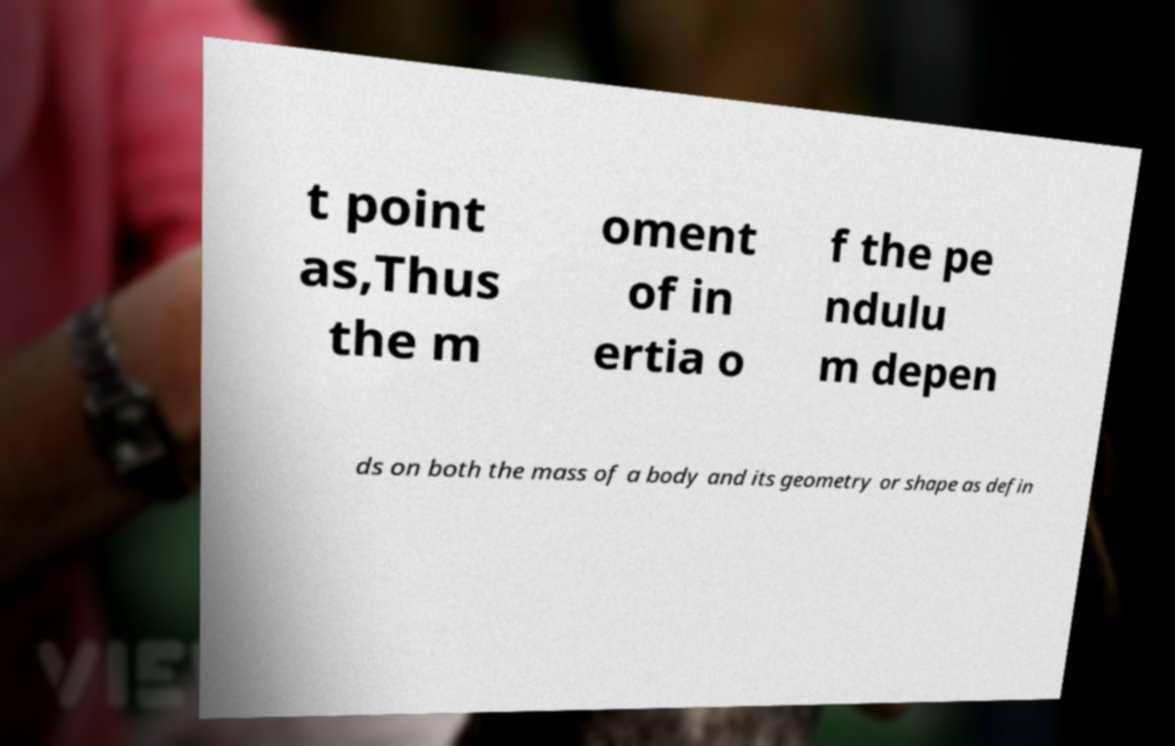Could you assist in decoding the text presented in this image and type it out clearly? t point as,Thus the m oment of in ertia o f the pe ndulu m depen ds on both the mass of a body and its geometry or shape as defin 